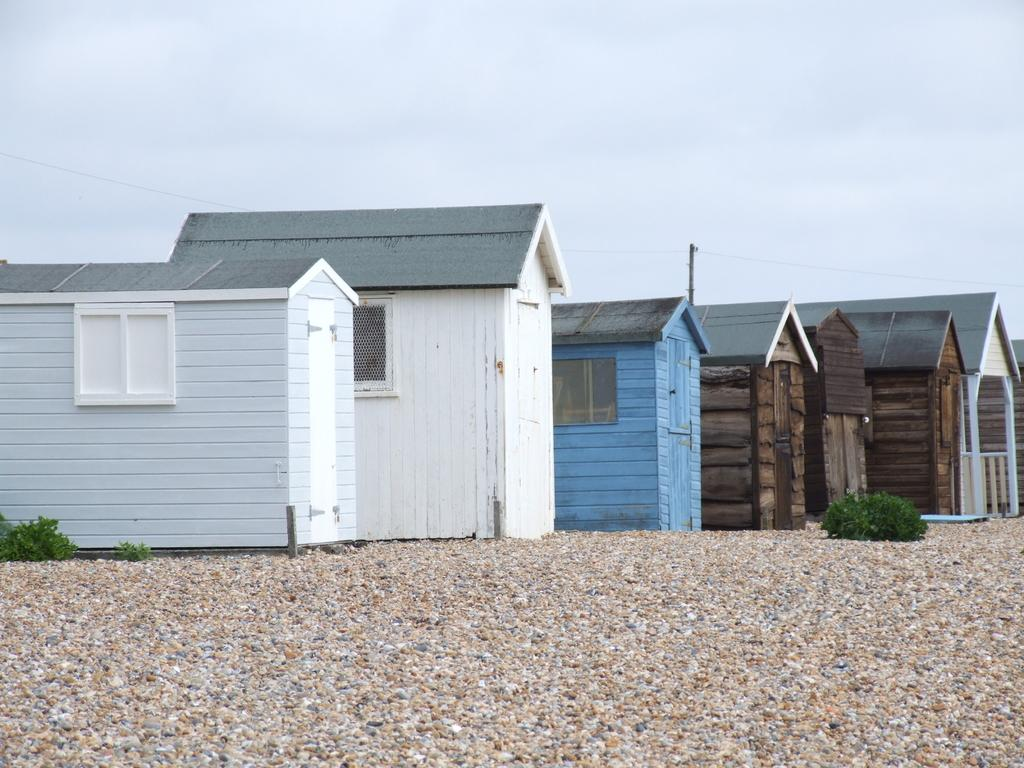What type of environment is depicted in the image? The image shows rooms and a stone surface, suggesting an indoor or partially enclosed outdoor setting. What can be seen growing in the image? There are plants visible in the image. What is visible in the background of the image? The sky is visible in the image. What type of pie is being served in the image? There is no pie present in the image. What kind of glue is being used to attach the plants to the stone surface? There is no glue or indication of any adhesive being used in the image. 